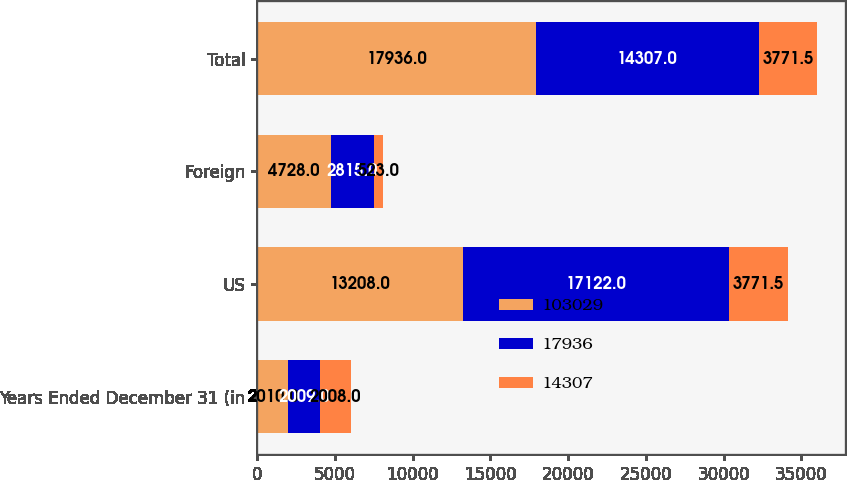<chart> <loc_0><loc_0><loc_500><loc_500><stacked_bar_chart><ecel><fcel>Years Ended December 31 (in<fcel>US<fcel>Foreign<fcel>Total<nl><fcel>103029<fcel>2010<fcel>13208<fcel>4728<fcel>17936<nl><fcel>17936<fcel>2009<fcel>17122<fcel>2815<fcel>14307<nl><fcel>14307<fcel>2008<fcel>3771.5<fcel>523<fcel>3771.5<nl></chart> 